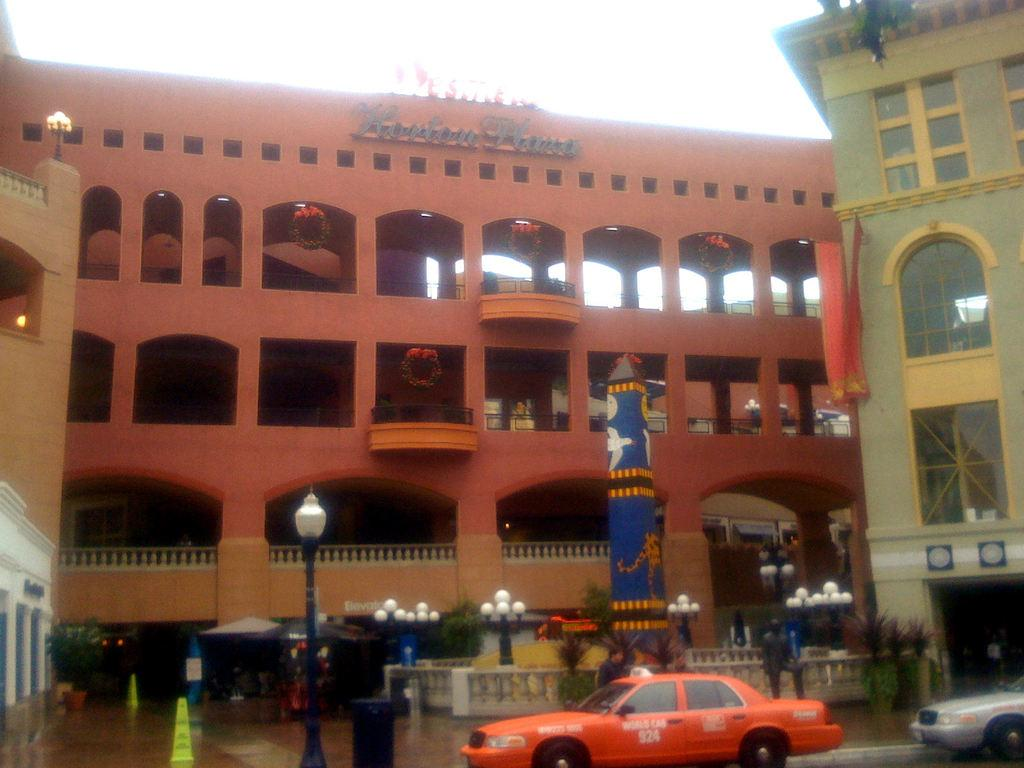<image>
Provide a brief description of the given image. A car in front of a red building, the car bearing the number 924. 